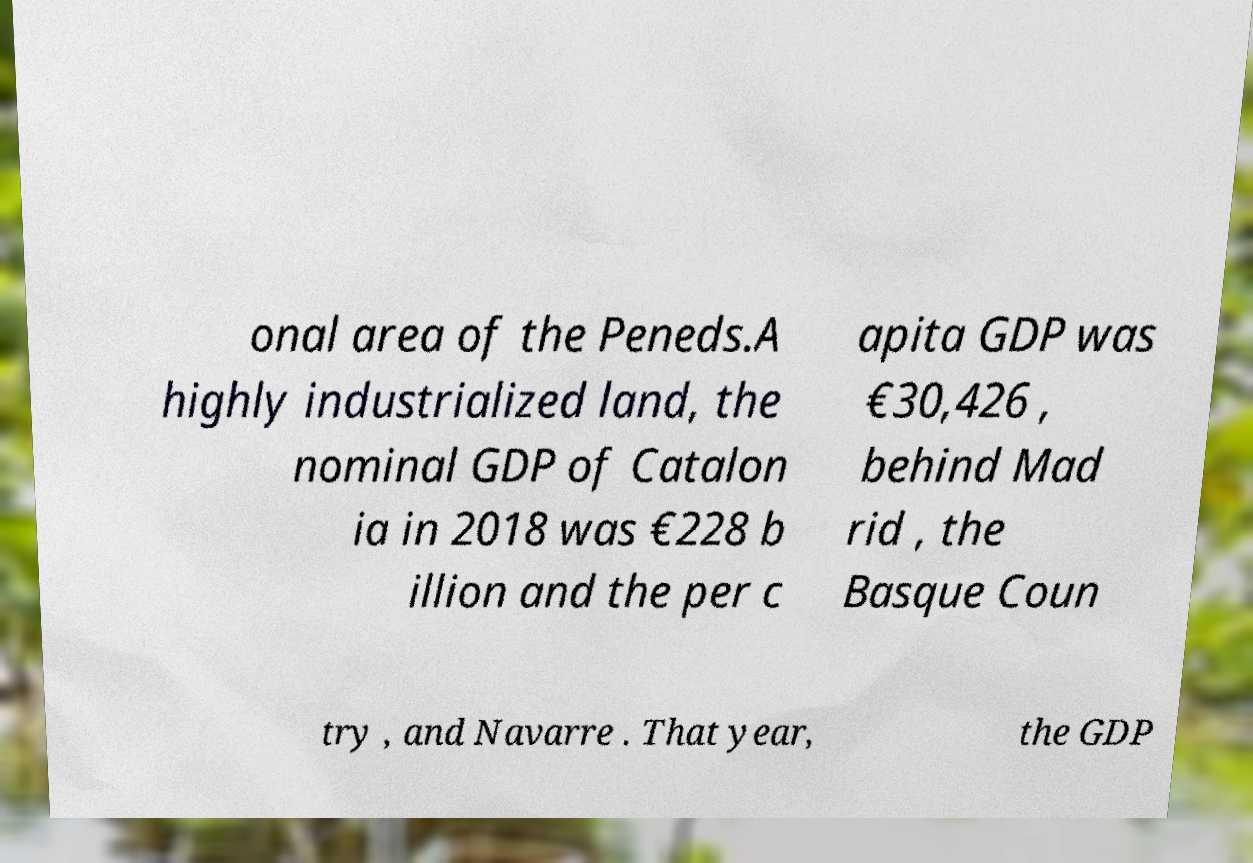What messages or text are displayed in this image? I need them in a readable, typed format. onal area of the Peneds.A highly industrialized land, the nominal GDP of Catalon ia in 2018 was €228 b illion and the per c apita GDP was €30,426 , behind Mad rid , the Basque Coun try , and Navarre . That year, the GDP 